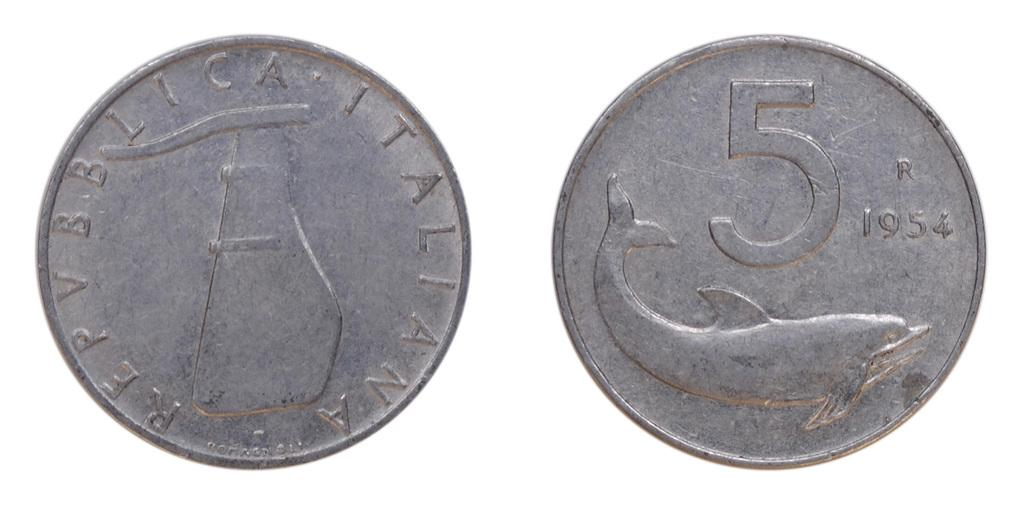<image>
Render a clear and concise summary of the photo. An old silver coin from 1954 has a dolphin on it. 